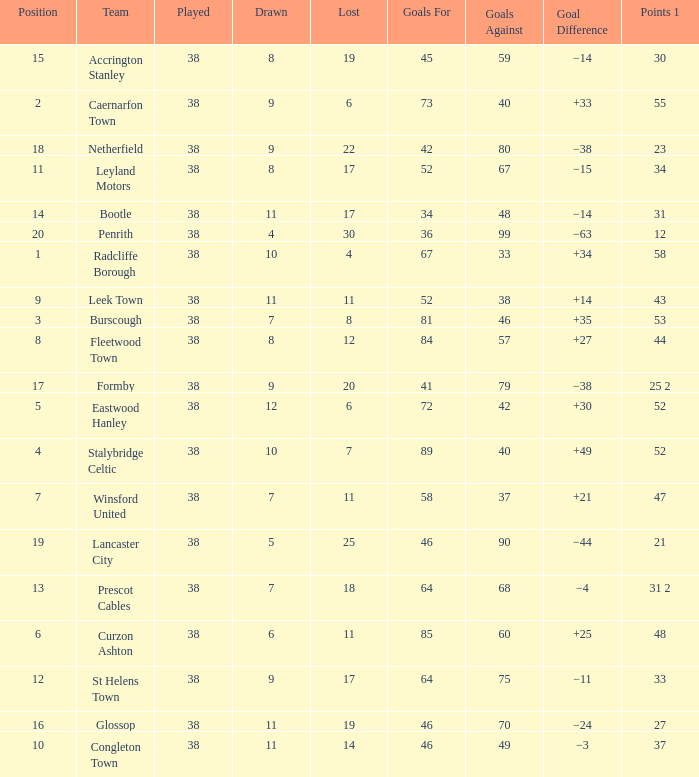WHAT POINTS 1 HAD A 22 LOST? 23.0. 